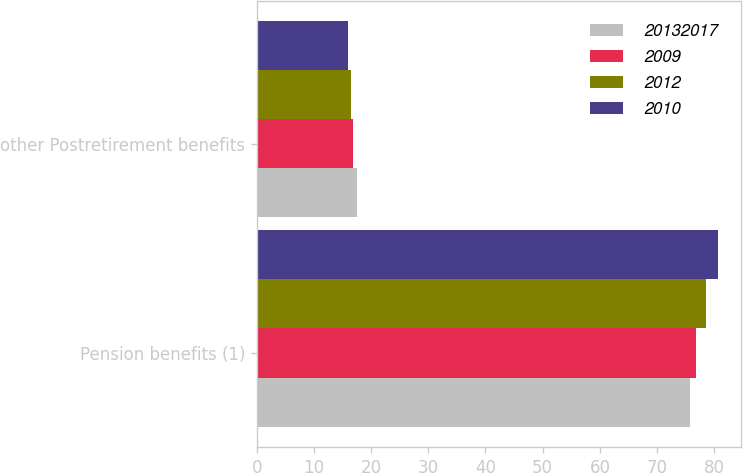<chart> <loc_0><loc_0><loc_500><loc_500><stacked_bar_chart><ecel><fcel>Pension benefits (1)<fcel>other Postretirement benefits<nl><fcel>2.0132e+07<fcel>75.7<fcel>17.6<nl><fcel>2009<fcel>76.8<fcel>16.9<nl><fcel>2012<fcel>78.6<fcel>16.4<nl><fcel>2010<fcel>80.6<fcel>15.9<nl></chart> 